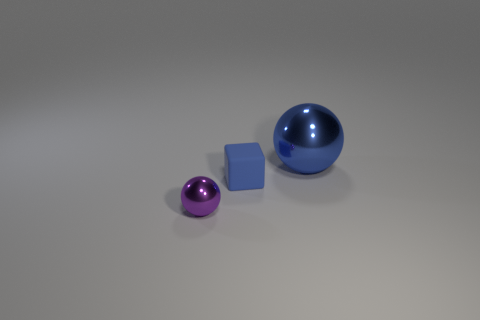Add 2 blue cubes. How many objects exist? 5 Subtract all blue spheres. How many spheres are left? 1 Subtract all balls. How many objects are left? 1 Subtract all brown cubes. How many blue balls are left? 1 Subtract all large red rubber cubes. Subtract all purple things. How many objects are left? 2 Add 3 purple shiny spheres. How many purple shiny spheres are left? 4 Add 2 tiny spheres. How many tiny spheres exist? 3 Subtract 0 red cubes. How many objects are left? 3 Subtract all green balls. Subtract all yellow cylinders. How many balls are left? 2 